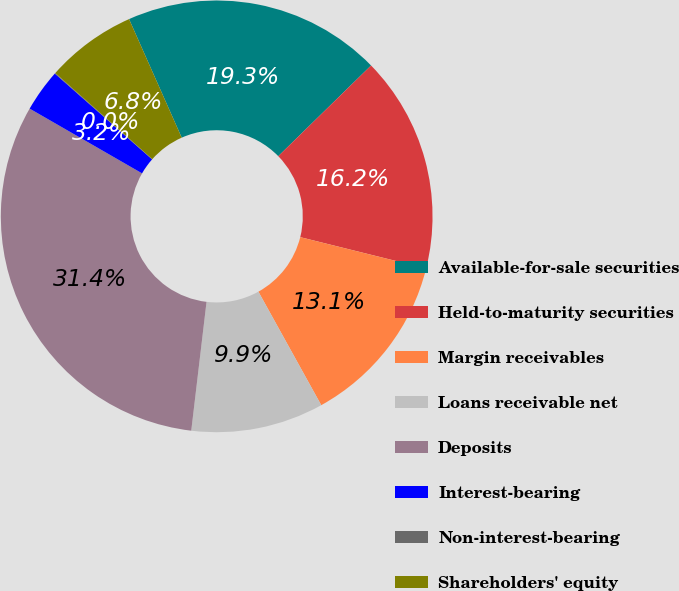Convert chart to OTSL. <chart><loc_0><loc_0><loc_500><loc_500><pie_chart><fcel>Available-for-sale securities<fcel>Held-to-maturity securities<fcel>Margin receivables<fcel>Loans receivable net<fcel>Deposits<fcel>Interest-bearing<fcel>Non-interest-bearing<fcel>Shareholders' equity<nl><fcel>19.34%<fcel>16.2%<fcel>13.07%<fcel>9.93%<fcel>31.44%<fcel>3.19%<fcel>0.05%<fcel>6.79%<nl></chart> 